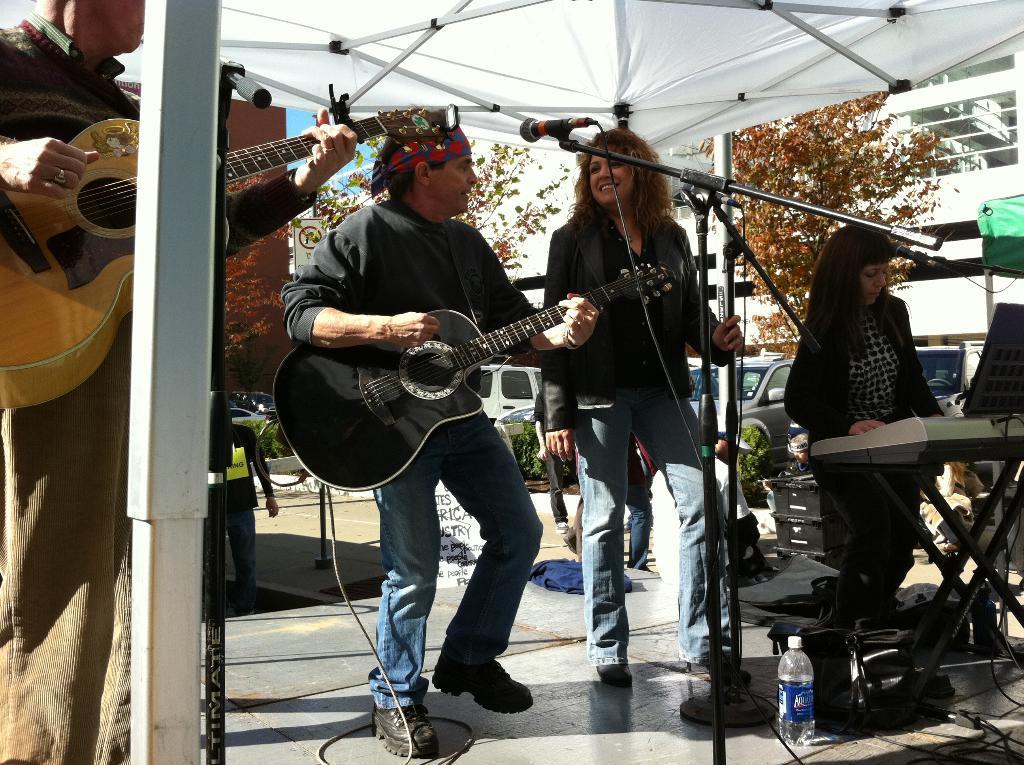Please provide a concise description of this image. In this picture there is a man playing a guitar. There is a woman standing. There is also another woman who is playing piano. There is a person holding a guitar. There is a mic. There is a tree, cars and building at the background. There is a sign board. There is a bottle and poster. 